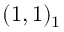Convert formula to latex. <formula><loc_0><loc_0><loc_500><loc_500>( 1 , 1 ) _ { 1 { { } } }</formula> 